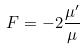<formula> <loc_0><loc_0><loc_500><loc_500>F = - 2 \frac { \mu ^ { \prime } } { \mu }</formula> 